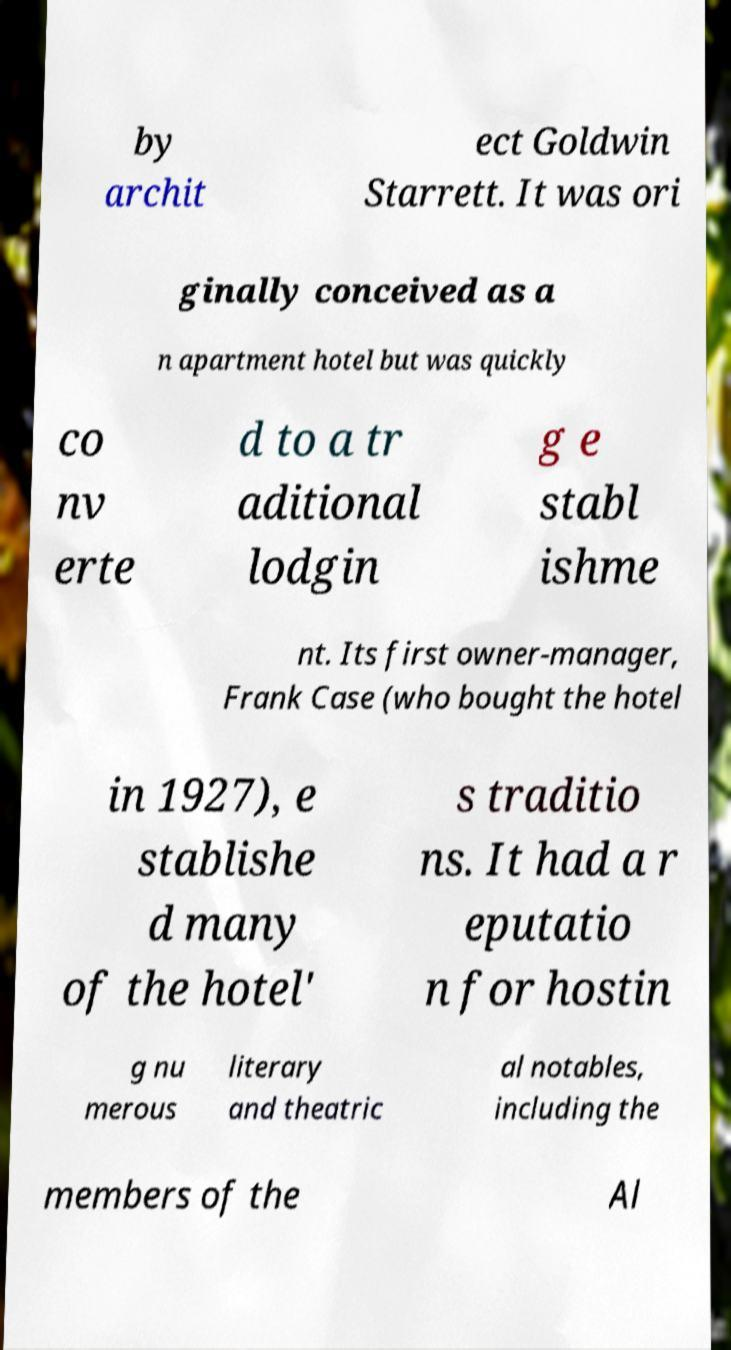Can you accurately transcribe the text from the provided image for me? by archit ect Goldwin Starrett. It was ori ginally conceived as a n apartment hotel but was quickly co nv erte d to a tr aditional lodgin g e stabl ishme nt. Its first owner-manager, Frank Case (who bought the hotel in 1927), e stablishe d many of the hotel' s traditio ns. It had a r eputatio n for hostin g nu merous literary and theatric al notables, including the members of the Al 